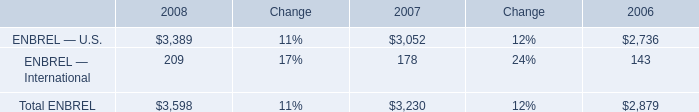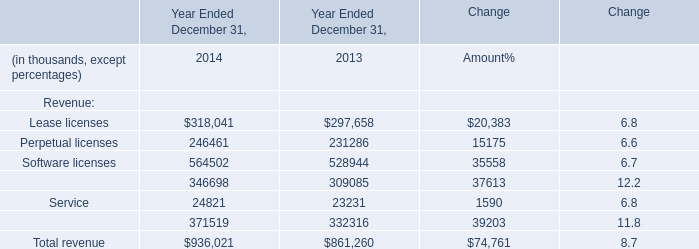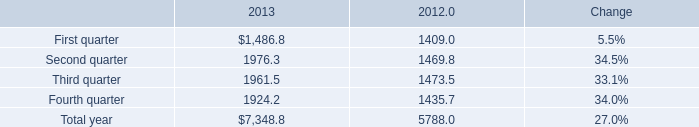What is the average amount of Service of Year Ended December 31, 2014, and Second quarter of 2012 ? 
Computations: ((24821.0 + 1469.8) / 2)
Answer: 13145.4. 